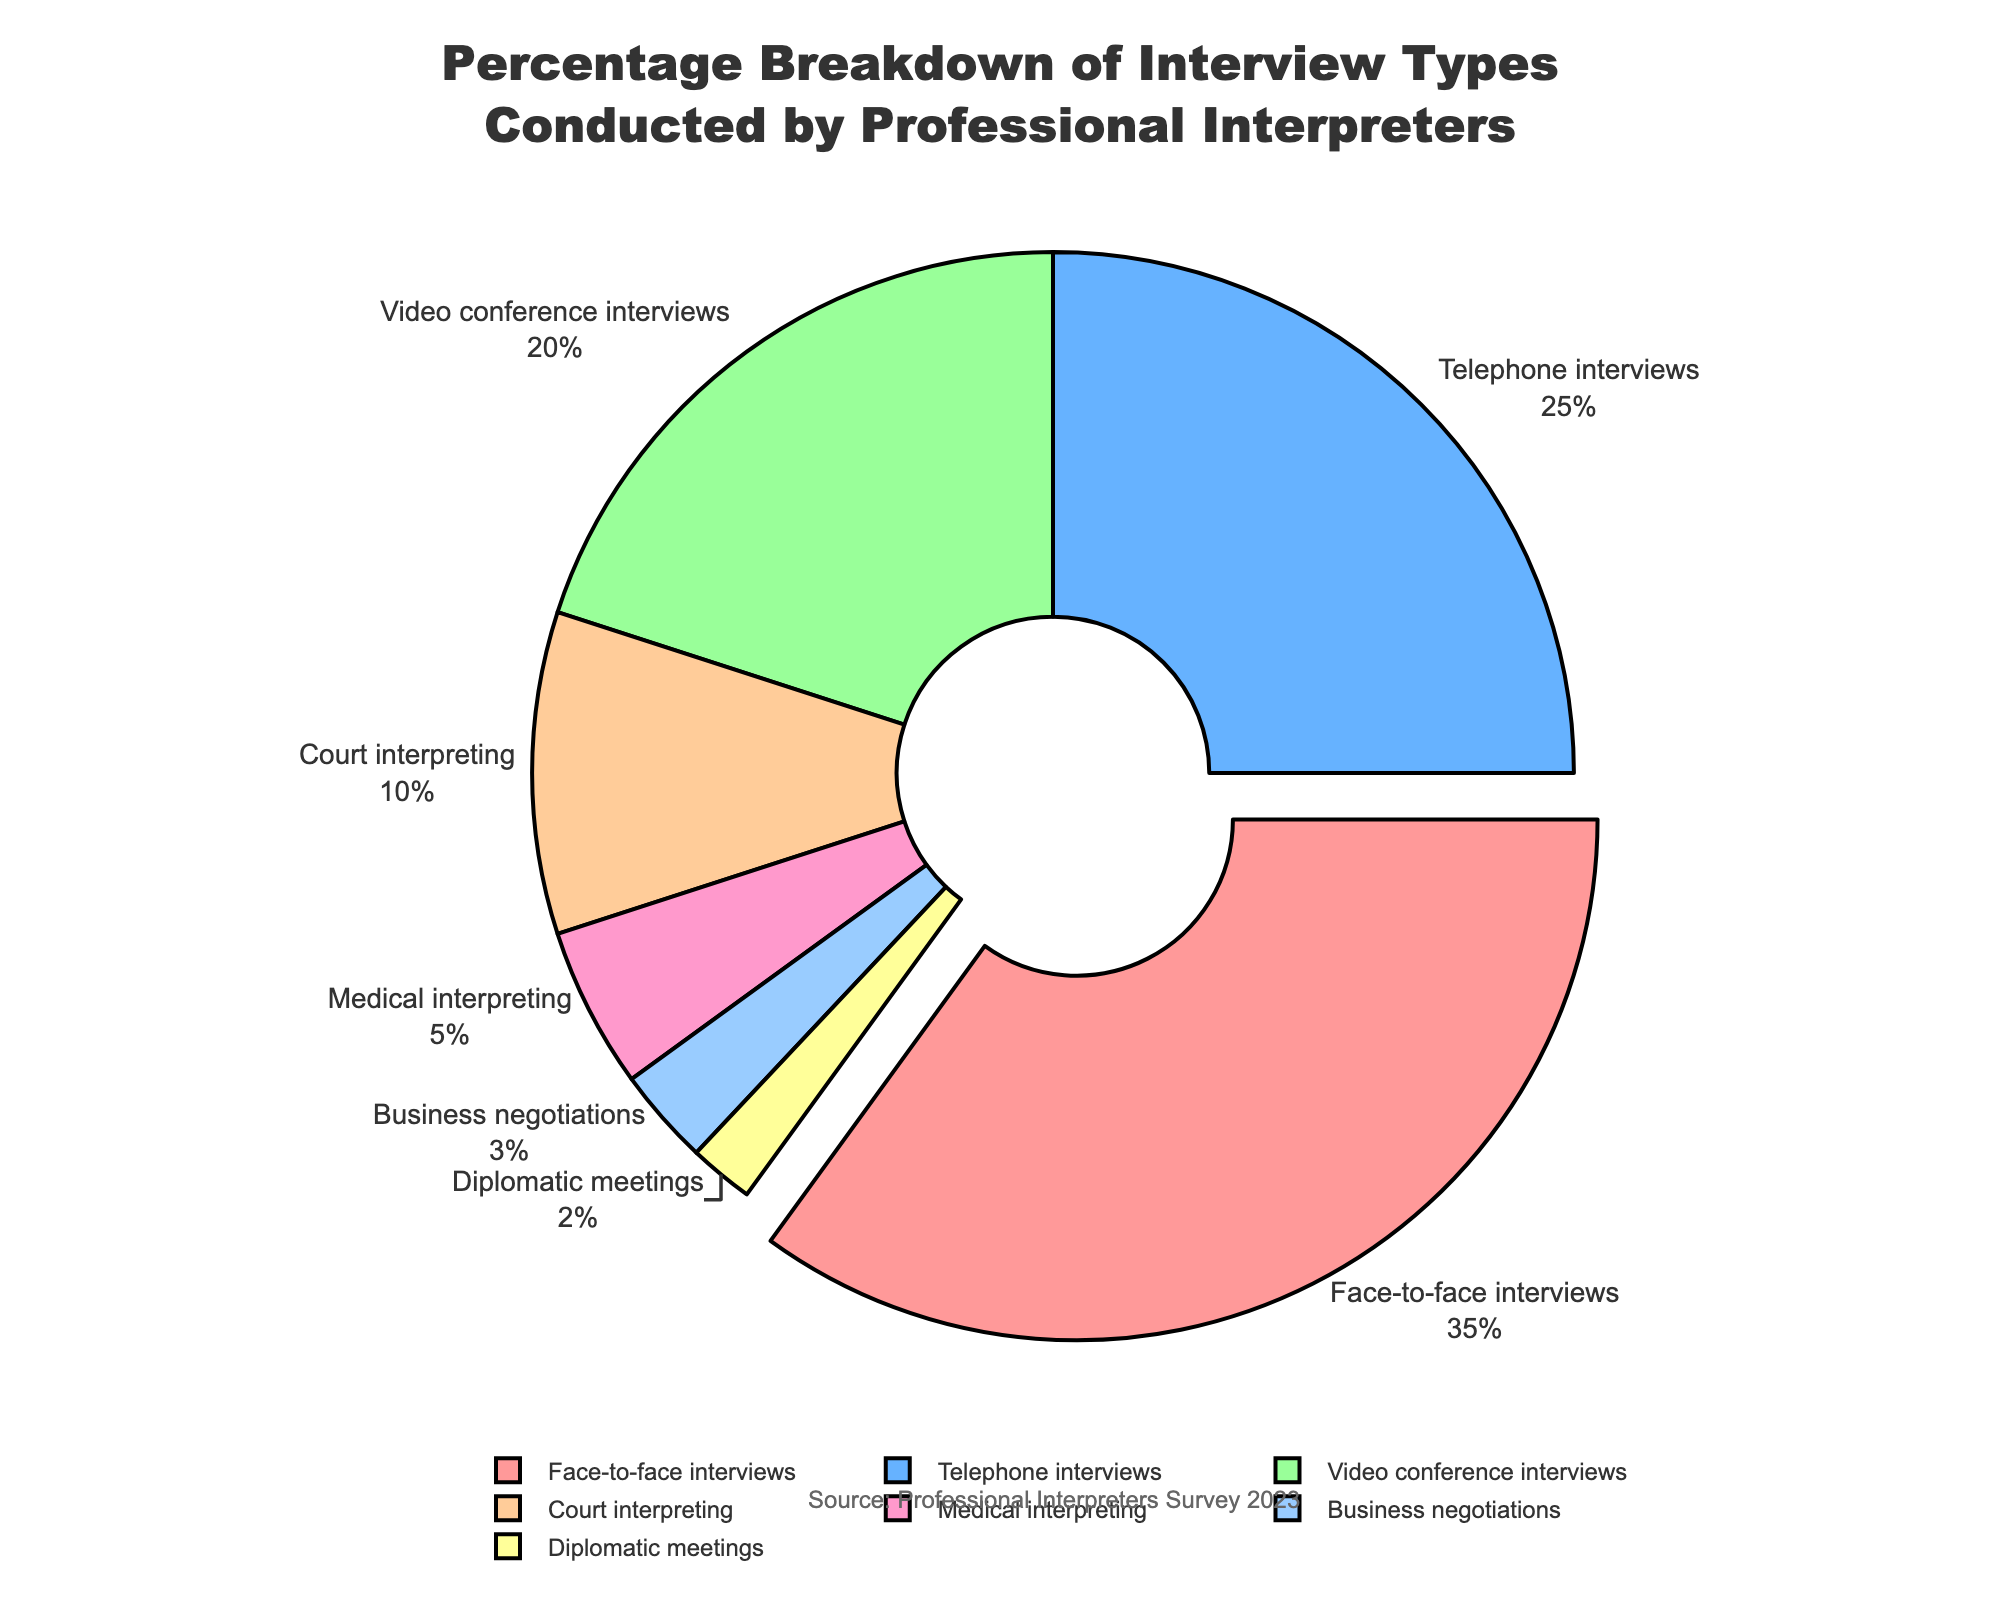What percentage of interviews are conducted as face-to-face interviews? Locate the segment labeled 'Face-to-face interviews' on the pie chart and read the displayed percentage.
Answer: 35% Which type of interview is the least common and what percentage does it represent? Find the smallest segment on the pie chart. It is labeled 'Diplomatic meetings'. The displayed percentage for this segment is 2%.
Answer: Diplomatic meetings, 2% What is the combined percentage of telephone and video conference interviews? Identify and sum the percentages for 'Telephone interviews' and 'Video conference interviews'. Telephone interviews are 25% and video conference interviews are 20%. So, 25 + 20 = 45%.
Answer: 45% How much larger is the percentage of medical interpreting than business negotiations? Identify the percentages for 'Medical interpreting' and 'Business negotiations'. Medical interpreting is 5%, business negotiations are 3%. Subtract the smaller percentage from the larger one: 5 - 3 = 2%.
Answer: 2% Which interview type has the highest percentage, and by how much is it larger than medical interpreting? First, identify the type with the highest percentage, which is 'Face-to-face interviews' at 35%. Then, identify 'Medical interpreting' at 5%. Subtract the percentage for medical interpreting from the percentage for face-to-face interviews: 35 - 5 = 30%.
Answer: Face-to-face interviews, 30% What is the combined percentage of court interpreting and business negotiations interviews? Locate the segments labeled 'Court interpreting' and 'Business negotiations' and sum their percentages. Court interpreting is 10%, and business negotiations represent 3%. So, 10 + 3 = 13%.
Answer: 13% How does the percentage of video conference interviews compare to the percentage of court interpreting interviews? Find the segments for 'Video conference interviews' (20%) and 'Court interpreting' (10%) and compare the percentages. 20% is double 10%.
Answer: Video conference interviews are double court interpreting Which segment is visually distinct and pulled outward from the pie chart? Identify the segment that appears to be pulled outward from the center of the pie chart. It is the segment labeled 'Face-to-face interviews'.
Answer: Face-to-face interviews Is the percentage of face-to-face interviews greater than the combined percentage of medical interpreting and business negotiations? Compare the percentage of 'Face-to-face interviews' (35%) with the sum of 'Medical interpreting' (5%) and 'Business negotiations' (3%). Add the latter two: 5 + 3 = 8%. Therefore, 35% is indeed greater than 8%.
Answer: Yes What is the combined percentage of all non-face-to-face interview types? Subtract the percentage of 'Face-to-face interviews' from 100%. The 'Face-to-face interviews' percentage is 35%, so 100 - 35 = 65%.
Answer: 65% 